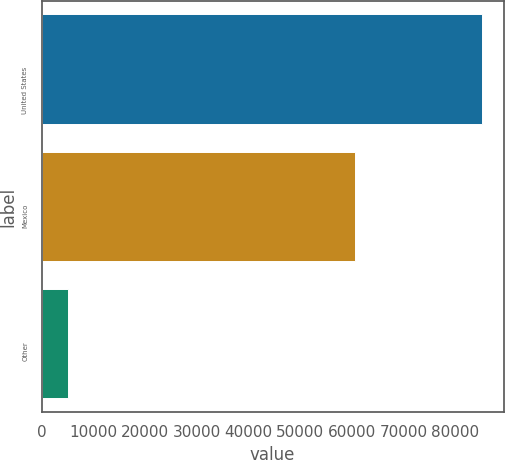<chart> <loc_0><loc_0><loc_500><loc_500><bar_chart><fcel>United States<fcel>Mexico<fcel>Other<nl><fcel>85072<fcel>60594<fcel>5172<nl></chart> 